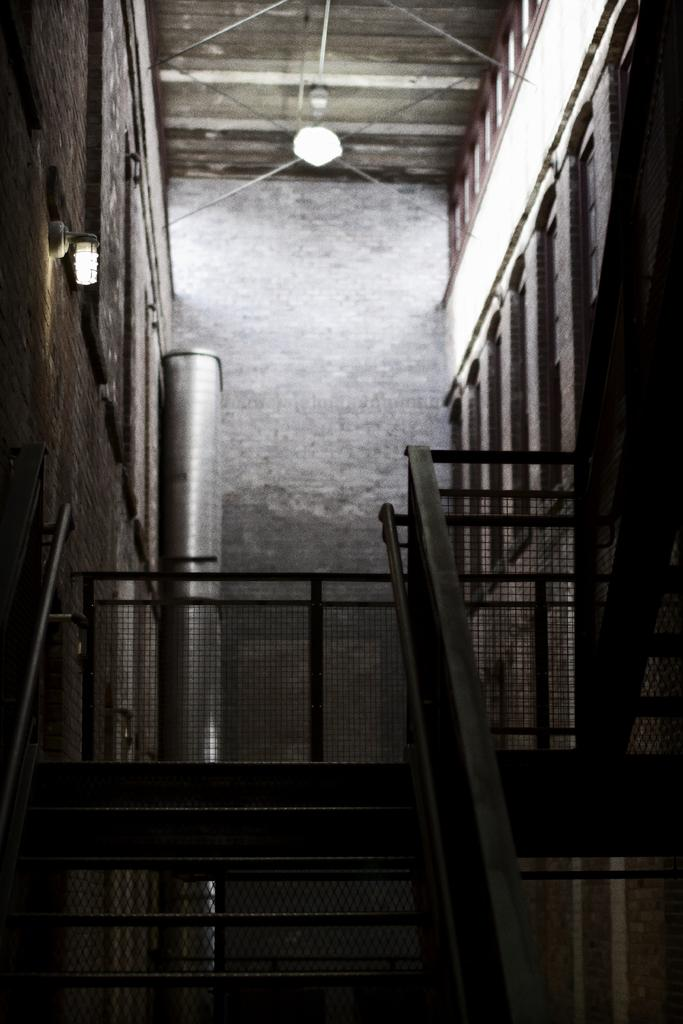What is located in the foreground of the image? In the foreground of the image, there are stairs, a railing, a wall, lights, and a metal pipe-like object. Can you describe the railing in the image? The railing in the image is located alongside the stairs and appears to provide support and safety. What type of lighting is present in the foreground of the image? The lights in the foreground of the image are likely designed to illuminate the area for visibility and safety. What is the purpose of the metal pipe-like object in the image? The purpose of the metal pipe-like object in the image is not explicitly stated, but it could be serving a structural or functional role. How many doctors are visible in the image? There are no doctors present in the image. Are there any spiders crawling on the railing in the image? There are no spiders visible in the image. 